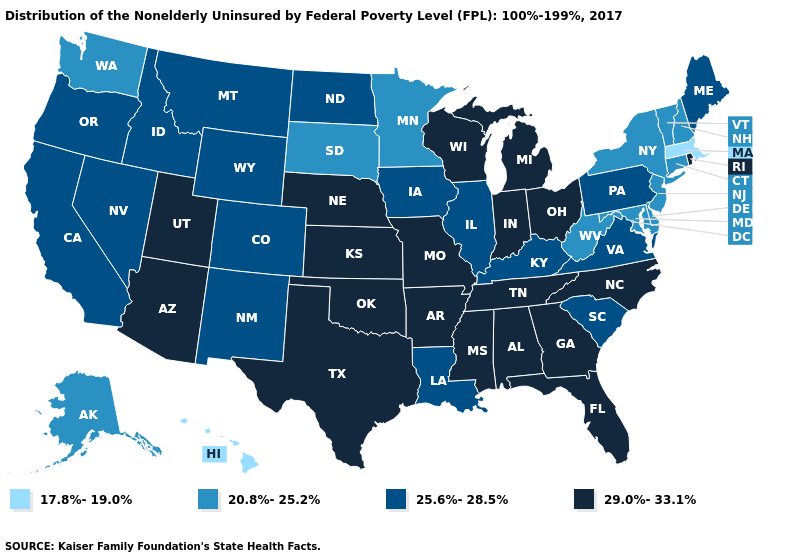How many symbols are there in the legend?
Concise answer only. 4. Name the states that have a value in the range 20.8%-25.2%?
Write a very short answer. Alaska, Connecticut, Delaware, Maryland, Minnesota, New Hampshire, New Jersey, New York, South Dakota, Vermont, Washington, West Virginia. Name the states that have a value in the range 29.0%-33.1%?
Give a very brief answer. Alabama, Arizona, Arkansas, Florida, Georgia, Indiana, Kansas, Michigan, Mississippi, Missouri, Nebraska, North Carolina, Ohio, Oklahoma, Rhode Island, Tennessee, Texas, Utah, Wisconsin. Does New Hampshire have the highest value in the USA?
Be succinct. No. Does the map have missing data?
Concise answer only. No. What is the value of North Carolina?
Write a very short answer. 29.0%-33.1%. Which states have the highest value in the USA?
Keep it brief. Alabama, Arizona, Arkansas, Florida, Georgia, Indiana, Kansas, Michigan, Mississippi, Missouri, Nebraska, North Carolina, Ohio, Oklahoma, Rhode Island, Tennessee, Texas, Utah, Wisconsin. What is the lowest value in the West?
Answer briefly. 17.8%-19.0%. What is the highest value in the South ?
Be succinct. 29.0%-33.1%. What is the highest value in states that border Kentucky?
Answer briefly. 29.0%-33.1%. Does Michigan have the same value as Minnesota?
Be succinct. No. Among the states that border Oklahoma , does Kansas have the lowest value?
Keep it brief. No. Name the states that have a value in the range 17.8%-19.0%?
Quick response, please. Hawaii, Massachusetts. Does West Virginia have the highest value in the South?
Be succinct. No. How many symbols are there in the legend?
Short answer required. 4. 